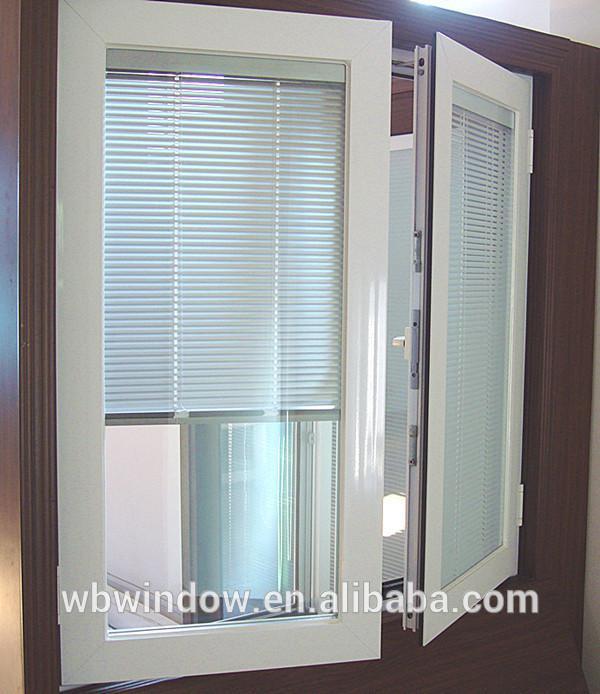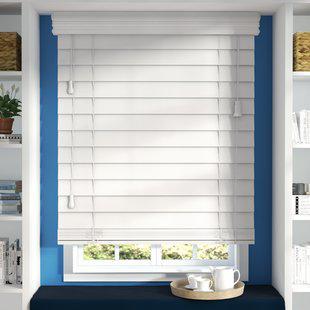The first image is the image on the left, the second image is the image on the right. For the images displayed, is the sentence "There are a total of four blinds." factually correct? Answer yes or no. No. The first image is the image on the left, the second image is the image on the right. Considering the images on both sides, is "At least two shades are partially pulled up." valid? Answer yes or no. Yes. 